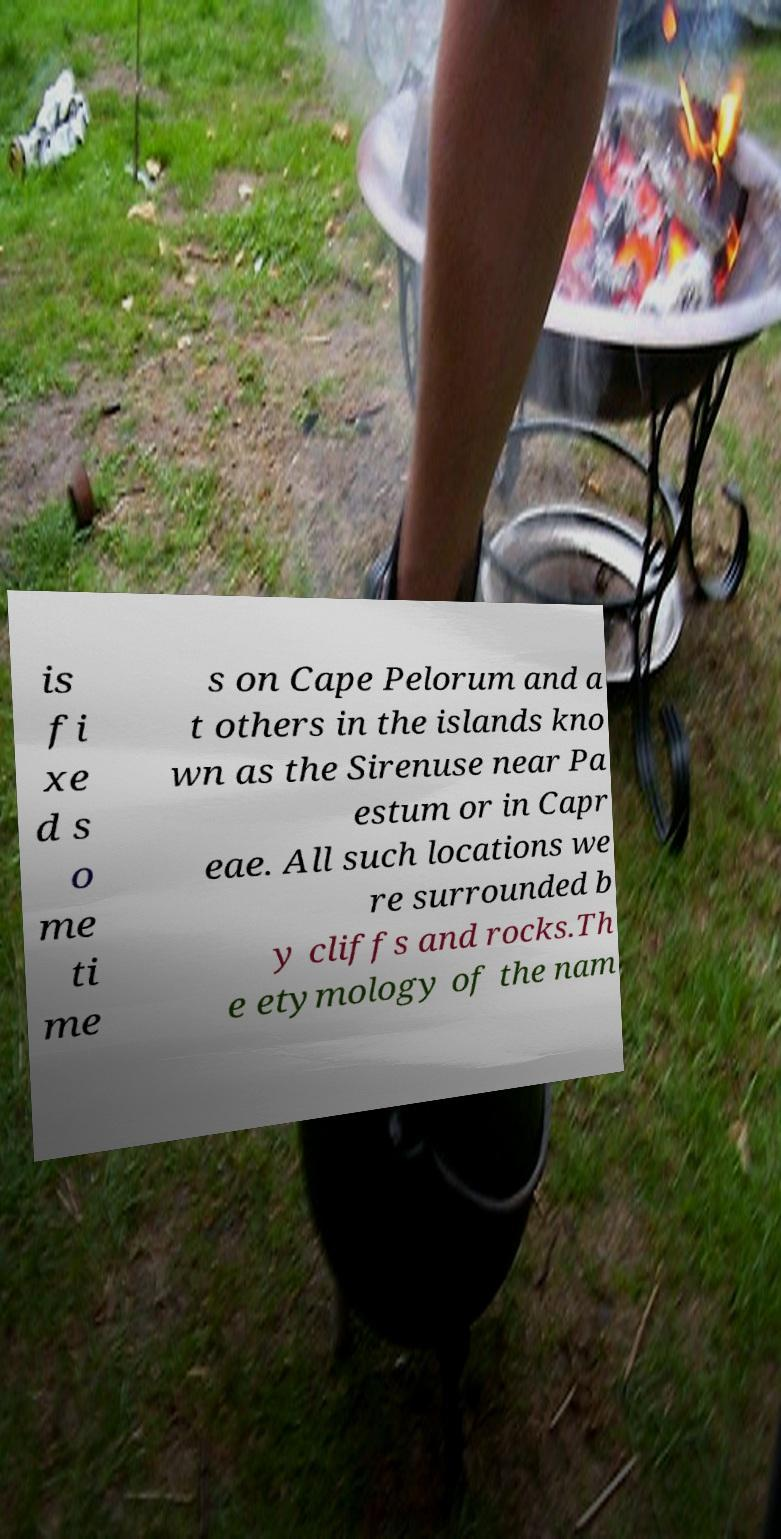Please identify and transcribe the text found in this image. is fi xe d s o me ti me s on Cape Pelorum and a t others in the islands kno wn as the Sirenuse near Pa estum or in Capr eae. All such locations we re surrounded b y cliffs and rocks.Th e etymology of the nam 